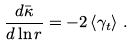Convert formula to latex. <formula><loc_0><loc_0><loc_500><loc_500>\frac { d \bar { \kappa } } { d \ln r } = - 2 \left \langle \gamma _ { t } \right \rangle \, .</formula> 